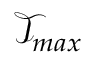Convert formula to latex. <formula><loc_0><loc_0><loc_500><loc_500>\mathcal { T } _ { \max }</formula> 